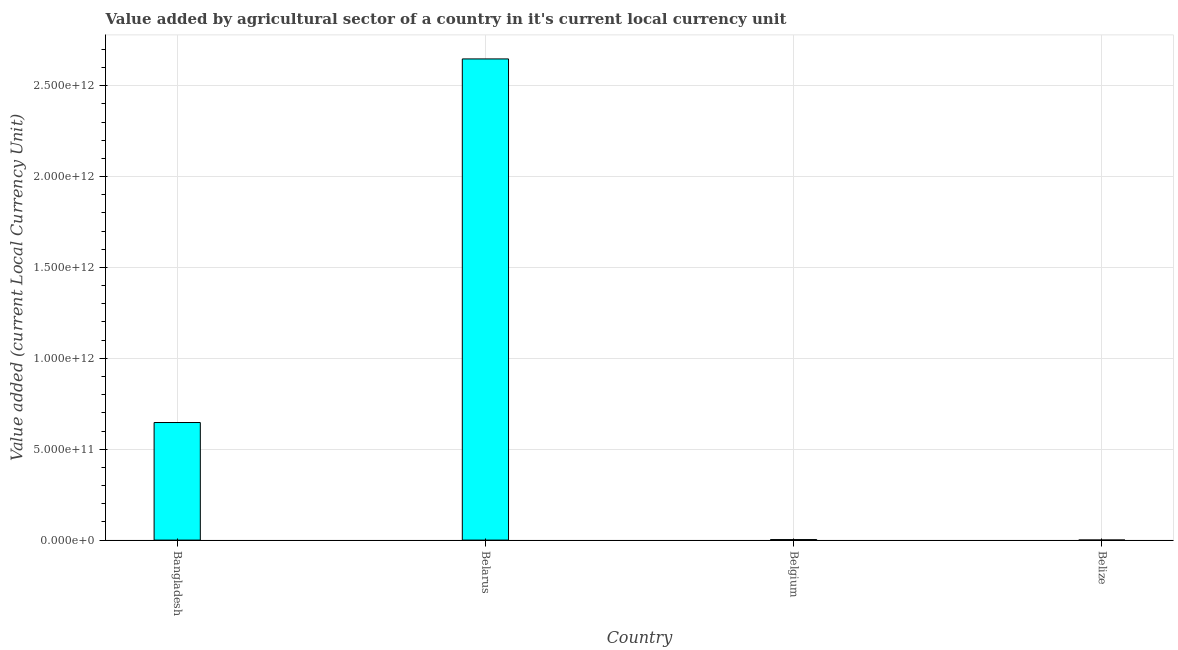Does the graph contain any zero values?
Give a very brief answer. No. Does the graph contain grids?
Your answer should be compact. Yes. What is the title of the graph?
Provide a succinct answer. Value added by agricultural sector of a country in it's current local currency unit. What is the label or title of the Y-axis?
Offer a terse response. Value added (current Local Currency Unit). What is the value added by agriculture sector in Bangladesh?
Your answer should be compact. 6.47e+11. Across all countries, what is the maximum value added by agriculture sector?
Offer a terse response. 2.65e+12. Across all countries, what is the minimum value added by agriculture sector?
Offer a very short reply. 2.46e+08. In which country was the value added by agriculture sector maximum?
Keep it short and to the point. Belarus. In which country was the value added by agriculture sector minimum?
Make the answer very short. Belize. What is the sum of the value added by agriculture sector?
Offer a terse response. 3.30e+12. What is the difference between the value added by agriculture sector in Bangladesh and Belgium?
Your response must be concise. 6.44e+11. What is the average value added by agriculture sector per country?
Your answer should be compact. 8.24e+11. What is the median value added by agriculture sector?
Provide a short and direct response. 3.25e+11. In how many countries, is the value added by agriculture sector greater than 1100000000000 LCU?
Make the answer very short. 1. What is the ratio of the value added by agriculture sector in Belarus to that in Belgium?
Ensure brevity in your answer.  937.47. Is the value added by agriculture sector in Bangladesh less than that in Belize?
Your response must be concise. No. Is the difference between the value added by agriculture sector in Bangladesh and Belgium greater than the difference between any two countries?
Your response must be concise. No. What is the difference between the highest and the second highest value added by agriculture sector?
Offer a terse response. 2.00e+12. What is the difference between the highest and the lowest value added by agriculture sector?
Provide a short and direct response. 2.65e+12. In how many countries, is the value added by agriculture sector greater than the average value added by agriculture sector taken over all countries?
Provide a succinct answer. 1. How many bars are there?
Keep it short and to the point. 4. Are all the bars in the graph horizontal?
Your answer should be compact. No. How many countries are there in the graph?
Give a very brief answer. 4. What is the difference between two consecutive major ticks on the Y-axis?
Keep it short and to the point. 5.00e+11. What is the Value added (current Local Currency Unit) in Bangladesh?
Your answer should be compact. 6.47e+11. What is the Value added (current Local Currency Unit) of Belarus?
Provide a short and direct response. 2.65e+12. What is the Value added (current Local Currency Unit) in Belgium?
Offer a very short reply. 2.82e+09. What is the Value added (current Local Currency Unit) in Belize?
Give a very brief answer. 2.46e+08. What is the difference between the Value added (current Local Currency Unit) in Bangladesh and Belarus?
Keep it short and to the point. -2.00e+12. What is the difference between the Value added (current Local Currency Unit) in Bangladesh and Belgium?
Provide a short and direct response. 6.44e+11. What is the difference between the Value added (current Local Currency Unit) in Bangladesh and Belize?
Provide a succinct answer. 6.47e+11. What is the difference between the Value added (current Local Currency Unit) in Belarus and Belgium?
Ensure brevity in your answer.  2.64e+12. What is the difference between the Value added (current Local Currency Unit) in Belarus and Belize?
Keep it short and to the point. 2.65e+12. What is the difference between the Value added (current Local Currency Unit) in Belgium and Belize?
Make the answer very short. 2.58e+09. What is the ratio of the Value added (current Local Currency Unit) in Bangladesh to that in Belarus?
Your answer should be compact. 0.24. What is the ratio of the Value added (current Local Currency Unit) in Bangladesh to that in Belgium?
Your answer should be compact. 229.08. What is the ratio of the Value added (current Local Currency Unit) in Bangladesh to that in Belize?
Your answer should be compact. 2633.6. What is the ratio of the Value added (current Local Currency Unit) in Belarus to that in Belgium?
Provide a short and direct response. 937.47. What is the ratio of the Value added (current Local Currency Unit) in Belarus to that in Belize?
Your answer should be very brief. 1.08e+04. What is the ratio of the Value added (current Local Currency Unit) in Belgium to that in Belize?
Your answer should be very brief. 11.5. 